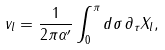<formula> <loc_0><loc_0><loc_500><loc_500>v _ { l } = \frac { 1 } { 2 \pi \alpha ^ { \prime } } \int _ { 0 } ^ { \pi } d \sigma \, \partial _ { \tau } X _ { l } ,</formula> 